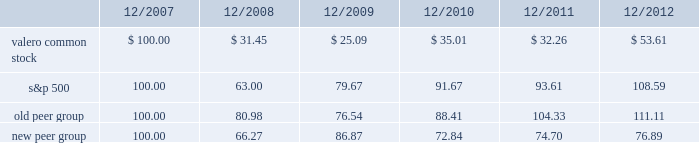Table of contents the following performance graph is not 201csoliciting material , 201d is not deemed filed with the sec , and is not to be incorporated by reference into any of valero 2019s filings under the securities act of 1933 or the securities exchange act of 1934 , as amended , respectively .
This performance graph and the related textual information are based on historical data and are not indicative of future performance .
The following line graph compares the cumulative total return 1 on an investment in our common stock against the cumulative total return of the s&p 500 composite index and an index of peer companies ( that we selected ) for the five-year period commencing december 31 , 2007 and ending december 31 , 2012 .
Our peer group consists of the following ten companies : alon usa energy , inc. ; bp plc ( bp ) ; cvr energy , inc. ; hess corporation ; hollyfrontier corporation ; marathon petroleum corporation ; phillips 66 ( psx ) ; royal dutch shell plc ( rds ) ; tesoro corporation ; and western refining , inc .
Our peer group previously included chevron corporation ( cvx ) and exxon mobil corporation ( xom ) but they were replaced with bp , psx , and rds .
In 2012 , psx became an independent downstream energy company and was added to our peer group .
Cvx and xom were replaced with bp and rds as they were viewed as having operations that more closely aligned with our core businesses .
Comparison of 5 year cumulative total return1 among valero energy corporation , the s&p 500 index , old peer group , and new peer group .
____________ 1 assumes that an investment in valero common stock and each index was $ 100 on december 31 , 2007 .
201ccumulative total return 201d is based on share price appreciation plus reinvestment of dividends from december 31 , 2007 through december 31 , 2012. .
What was the percentage growth of the s&p 500 common stock from 2007 to 2012? 
Computations: ((108.59 - 100.00) / 100.00)
Answer: 0.0859. 